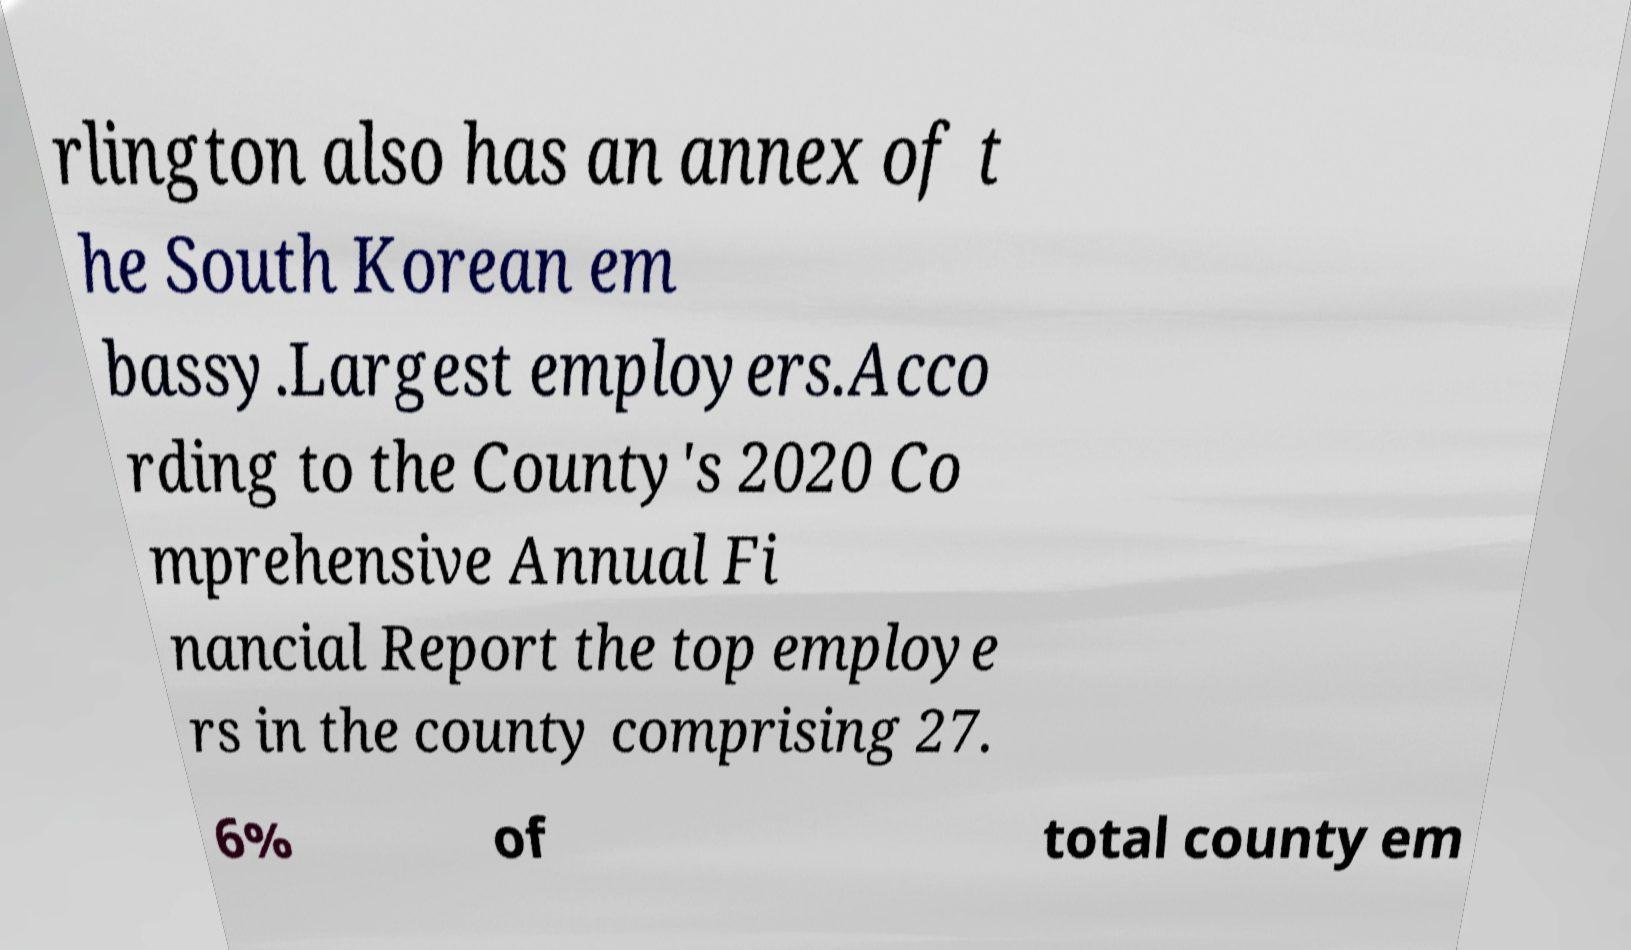Can you read and provide the text displayed in the image?This photo seems to have some interesting text. Can you extract and type it out for me? rlington also has an annex of t he South Korean em bassy.Largest employers.Acco rding to the County's 2020 Co mprehensive Annual Fi nancial Report the top employe rs in the county comprising 27. 6% of total county em 